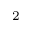Convert formula to latex. <formula><loc_0><loc_0><loc_500><loc_500>^ { 2 }</formula> 